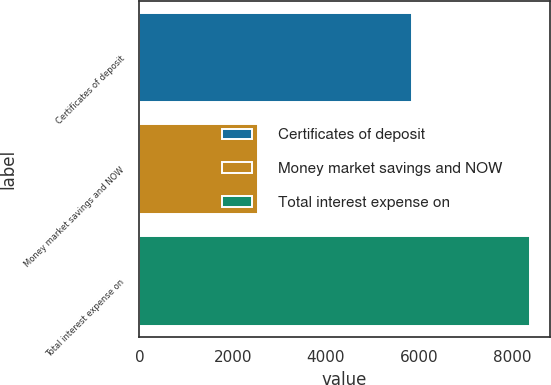Convert chart to OTSL. <chart><loc_0><loc_0><loc_500><loc_500><bar_chart><fcel>Certificates of deposit<fcel>Money market savings and NOW<fcel>Total interest expense on<nl><fcel>5839<fcel>2543<fcel>8382<nl></chart> 